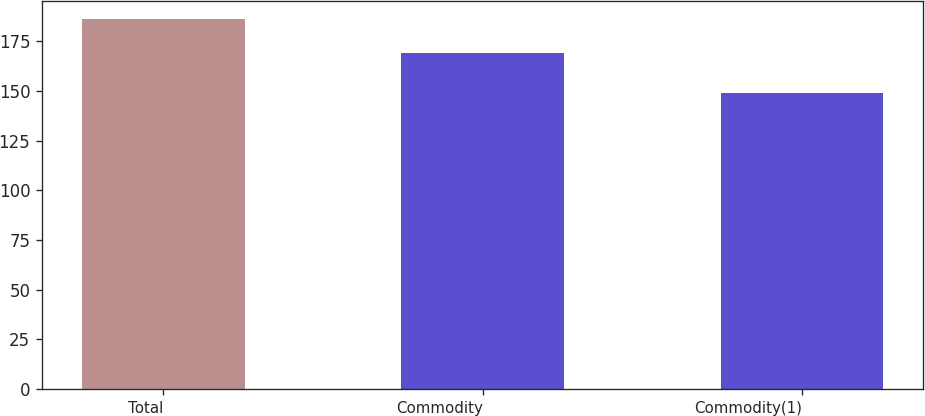Convert chart. <chart><loc_0><loc_0><loc_500><loc_500><bar_chart><fcel>Total<fcel>Commodity<fcel>Commodity(1)<nl><fcel>186<fcel>169<fcel>149<nl></chart> 